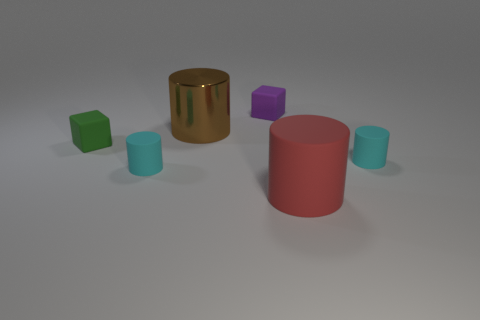How many brown things have the same size as the red thing?
Keep it short and to the point. 1. There is a large brown object that is the same shape as the red thing; what is it made of?
Your answer should be very brief. Metal. What is the shape of the tiny matte thing that is right of the green rubber block and left of the brown cylinder?
Offer a very short reply. Cylinder. What is the shape of the big thing behind the tiny green thing?
Give a very brief answer. Cylinder. How many objects are in front of the purple block and behind the green rubber object?
Keep it short and to the point. 1. There is a brown metal cylinder; is its size the same as the block that is behind the green rubber thing?
Ensure brevity in your answer.  No. What size is the thing in front of the cyan cylinder that is in front of the object to the right of the big red thing?
Offer a terse response. Large. What size is the cyan cylinder that is left of the purple rubber block?
Your answer should be very brief. Small. What is the shape of the green object that is the same material as the big red cylinder?
Your answer should be compact. Cube. Is the material of the small object on the right side of the red matte cylinder the same as the big brown thing?
Offer a very short reply. No. 